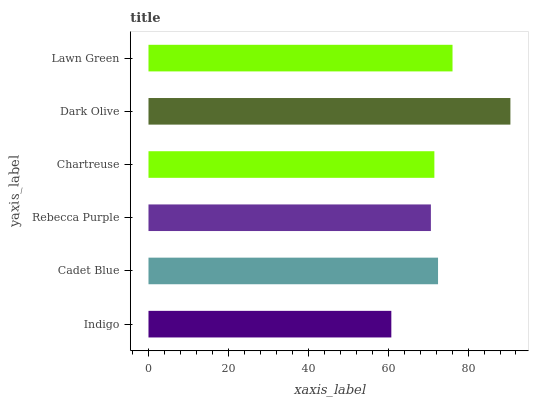Is Indigo the minimum?
Answer yes or no. Yes. Is Dark Olive the maximum?
Answer yes or no. Yes. Is Cadet Blue the minimum?
Answer yes or no. No. Is Cadet Blue the maximum?
Answer yes or no. No. Is Cadet Blue greater than Indigo?
Answer yes or no. Yes. Is Indigo less than Cadet Blue?
Answer yes or no. Yes. Is Indigo greater than Cadet Blue?
Answer yes or no. No. Is Cadet Blue less than Indigo?
Answer yes or no. No. Is Cadet Blue the high median?
Answer yes or no. Yes. Is Chartreuse the low median?
Answer yes or no. Yes. Is Lawn Green the high median?
Answer yes or no. No. Is Cadet Blue the low median?
Answer yes or no. No. 